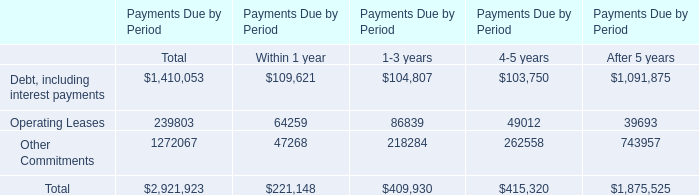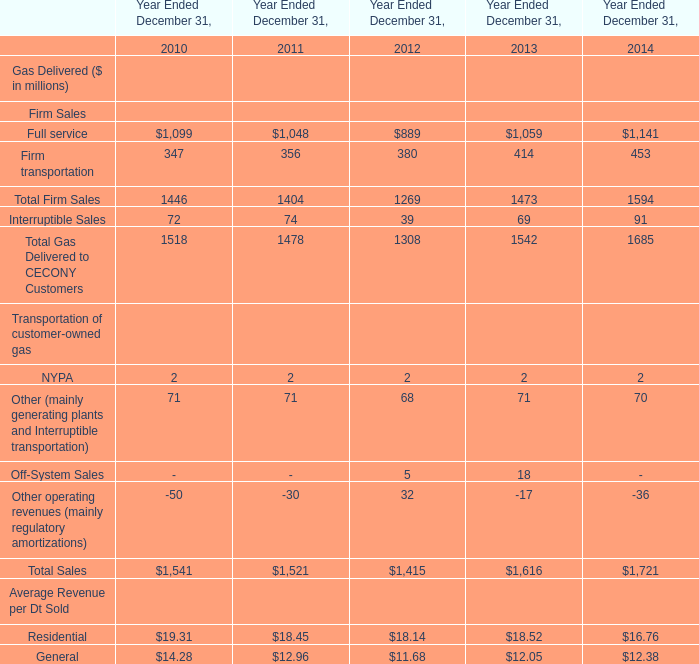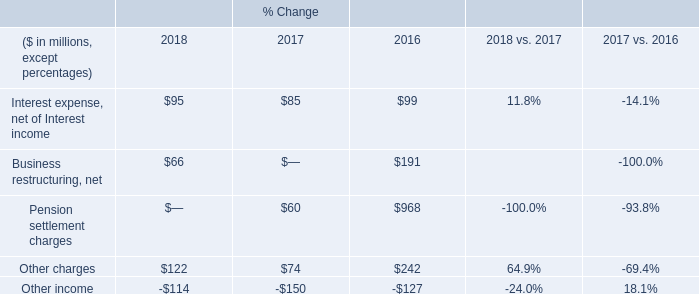what's the total amount of Full service of Year Ended December 31, 2013, and Operating Leases of Payments Due by Period After 5 years ? 
Computations: (1059.0 + 39693.0)
Answer: 40752.0. 